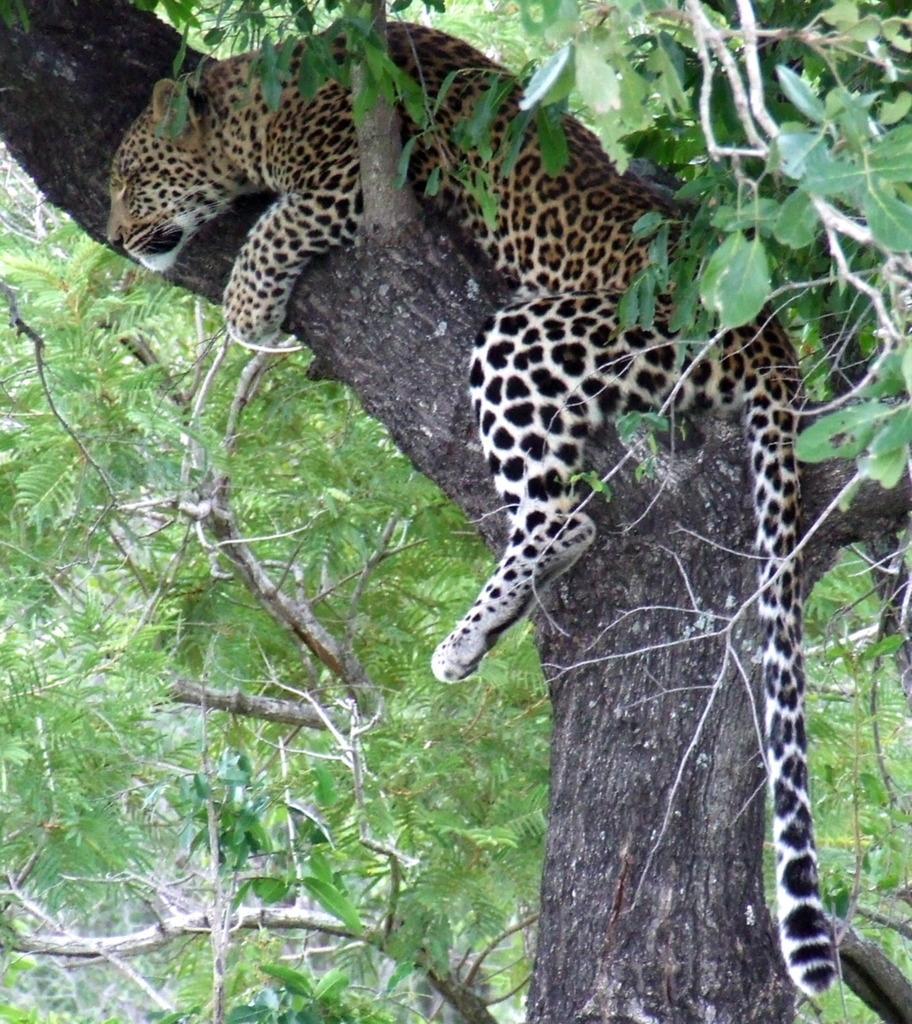How would you summarize this image in a sentence or two? In this image we can see cheetah which is on the tree. In the background we can see branches. 